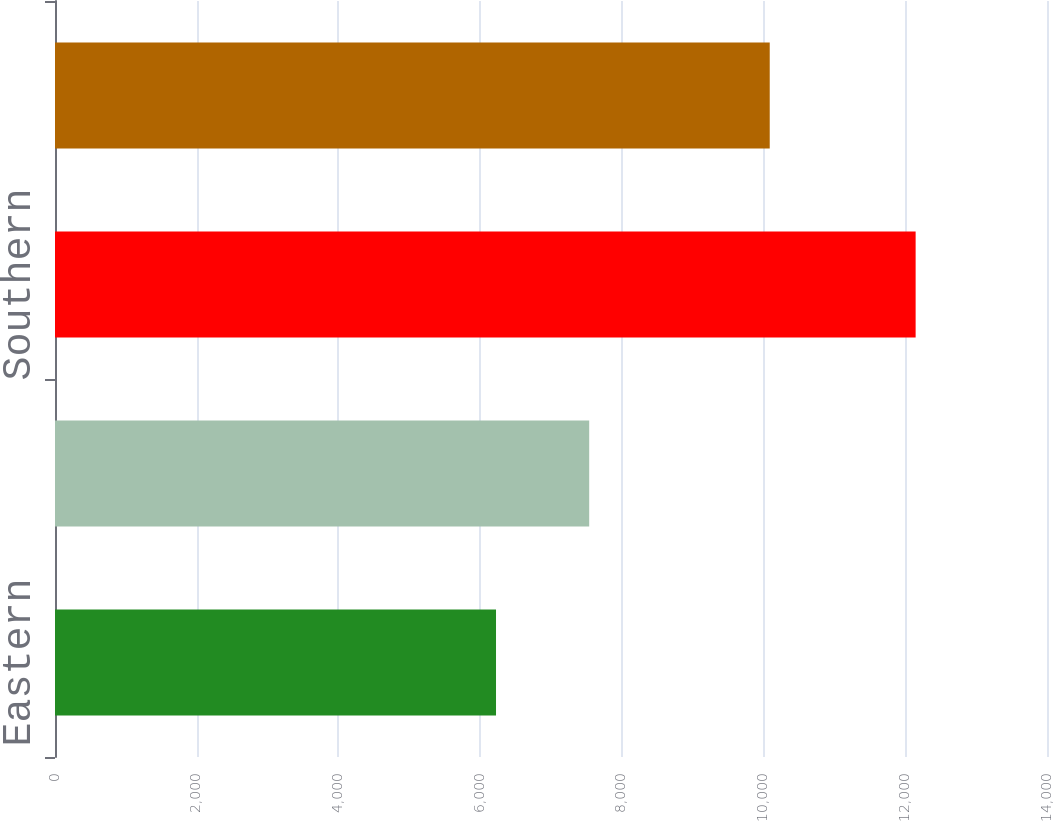Convert chart. <chart><loc_0><loc_0><loc_500><loc_500><bar_chart><fcel>Eastern<fcel>Midwest<fcel>Southern<fcel>Western<nl><fcel>6224<fcel>7539<fcel>12146<fcel>10087<nl></chart> 